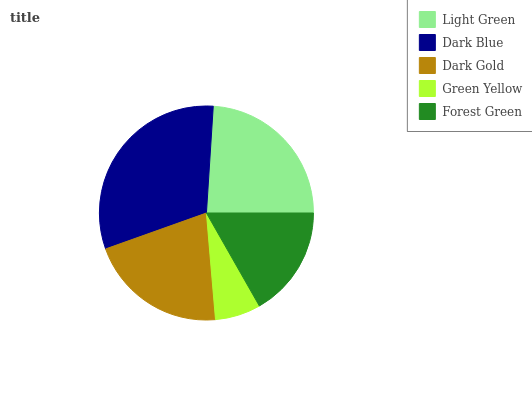Is Green Yellow the minimum?
Answer yes or no. Yes. Is Dark Blue the maximum?
Answer yes or no. Yes. Is Dark Gold the minimum?
Answer yes or no. No. Is Dark Gold the maximum?
Answer yes or no. No. Is Dark Blue greater than Dark Gold?
Answer yes or no. Yes. Is Dark Gold less than Dark Blue?
Answer yes or no. Yes. Is Dark Gold greater than Dark Blue?
Answer yes or no. No. Is Dark Blue less than Dark Gold?
Answer yes or no. No. Is Dark Gold the high median?
Answer yes or no. Yes. Is Dark Gold the low median?
Answer yes or no. Yes. Is Green Yellow the high median?
Answer yes or no. No. Is Dark Blue the low median?
Answer yes or no. No. 